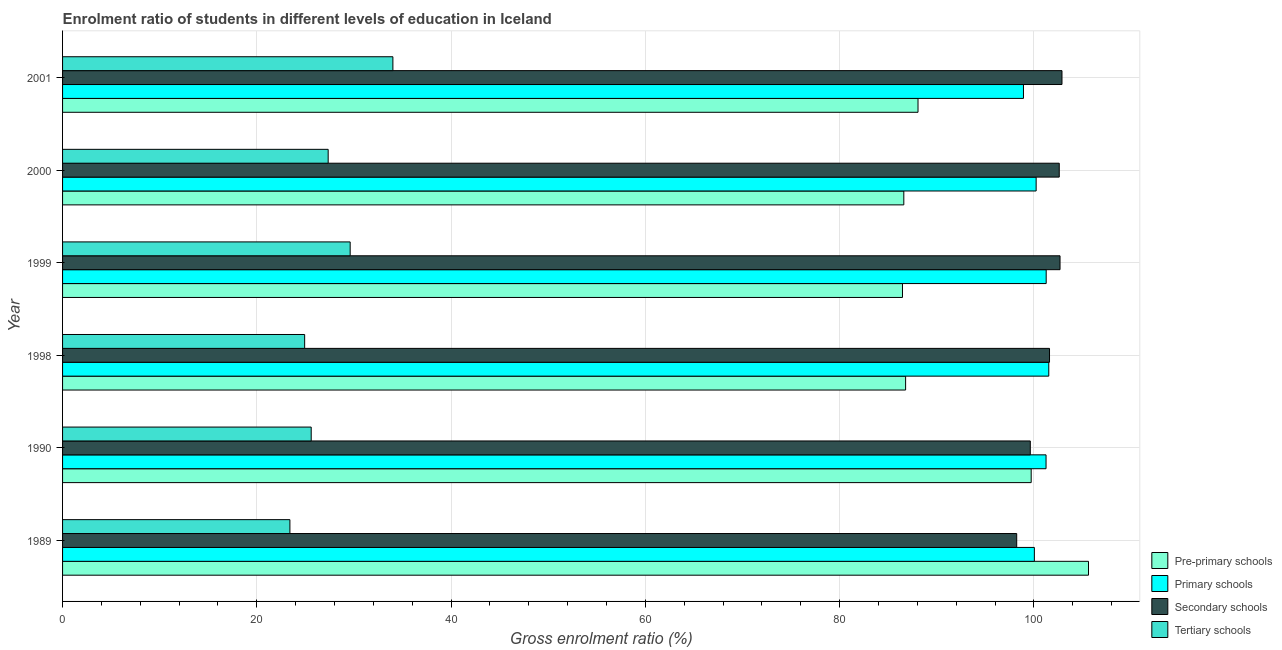How many groups of bars are there?
Offer a very short reply. 6. Are the number of bars on each tick of the Y-axis equal?
Offer a terse response. Yes. How many bars are there on the 5th tick from the bottom?
Your answer should be very brief. 4. In how many cases, is the number of bars for a given year not equal to the number of legend labels?
Keep it short and to the point. 0. What is the gross enrolment ratio in primary schools in 1999?
Your response must be concise. 101.26. Across all years, what is the maximum gross enrolment ratio in tertiary schools?
Give a very brief answer. 34.01. Across all years, what is the minimum gross enrolment ratio in pre-primary schools?
Your answer should be very brief. 86.47. In which year was the gross enrolment ratio in primary schools maximum?
Ensure brevity in your answer.  1998. In which year was the gross enrolment ratio in secondary schools minimum?
Give a very brief answer. 1989. What is the total gross enrolment ratio in pre-primary schools in the graph?
Keep it short and to the point. 553.26. What is the difference between the gross enrolment ratio in tertiary schools in 1989 and that in 1990?
Ensure brevity in your answer.  -2.19. What is the difference between the gross enrolment ratio in tertiary schools in 2001 and the gross enrolment ratio in primary schools in 2000?
Provide a short and direct response. -66.22. What is the average gross enrolment ratio in pre-primary schools per year?
Your response must be concise. 92.21. In the year 1999, what is the difference between the gross enrolment ratio in primary schools and gross enrolment ratio in pre-primary schools?
Your answer should be compact. 14.79. What is the ratio of the gross enrolment ratio in pre-primary schools in 1989 to that in 1999?
Keep it short and to the point. 1.22. Is the difference between the gross enrolment ratio in secondary schools in 2000 and 2001 greater than the difference between the gross enrolment ratio in primary schools in 2000 and 2001?
Make the answer very short. No. What is the difference between the highest and the second highest gross enrolment ratio in tertiary schools?
Your answer should be very brief. 4.4. What is the difference between the highest and the lowest gross enrolment ratio in tertiary schools?
Ensure brevity in your answer.  10.6. In how many years, is the gross enrolment ratio in primary schools greater than the average gross enrolment ratio in primary schools taken over all years?
Give a very brief answer. 3. What does the 4th bar from the top in 1998 represents?
Make the answer very short. Pre-primary schools. What does the 1st bar from the bottom in 1998 represents?
Offer a terse response. Pre-primary schools. How many bars are there?
Your answer should be very brief. 24. How many years are there in the graph?
Make the answer very short. 6. What is the difference between two consecutive major ticks on the X-axis?
Make the answer very short. 20. Are the values on the major ticks of X-axis written in scientific E-notation?
Provide a succinct answer. No. Does the graph contain grids?
Give a very brief answer. Yes. How many legend labels are there?
Make the answer very short. 4. What is the title of the graph?
Ensure brevity in your answer.  Enrolment ratio of students in different levels of education in Iceland. What is the Gross enrolment ratio (%) of Pre-primary schools in 1989?
Provide a succinct answer. 105.62. What is the Gross enrolment ratio (%) in Primary schools in 1989?
Offer a terse response. 100.04. What is the Gross enrolment ratio (%) of Secondary schools in 1989?
Your answer should be very brief. 98.23. What is the Gross enrolment ratio (%) in Tertiary schools in 1989?
Keep it short and to the point. 23.4. What is the Gross enrolment ratio (%) of Pre-primary schools in 1990?
Ensure brevity in your answer.  99.72. What is the Gross enrolment ratio (%) of Primary schools in 1990?
Keep it short and to the point. 101.25. What is the Gross enrolment ratio (%) of Secondary schools in 1990?
Make the answer very short. 99.62. What is the Gross enrolment ratio (%) of Tertiary schools in 1990?
Make the answer very short. 25.6. What is the Gross enrolment ratio (%) in Pre-primary schools in 1998?
Your response must be concise. 86.79. What is the Gross enrolment ratio (%) in Primary schools in 1998?
Ensure brevity in your answer.  101.53. What is the Gross enrolment ratio (%) of Secondary schools in 1998?
Offer a terse response. 101.6. What is the Gross enrolment ratio (%) in Tertiary schools in 1998?
Ensure brevity in your answer.  24.92. What is the Gross enrolment ratio (%) in Pre-primary schools in 1999?
Your answer should be compact. 86.47. What is the Gross enrolment ratio (%) in Primary schools in 1999?
Make the answer very short. 101.26. What is the Gross enrolment ratio (%) of Secondary schools in 1999?
Give a very brief answer. 102.69. What is the Gross enrolment ratio (%) in Tertiary schools in 1999?
Keep it short and to the point. 29.61. What is the Gross enrolment ratio (%) of Pre-primary schools in 2000?
Give a very brief answer. 86.6. What is the Gross enrolment ratio (%) of Primary schools in 2000?
Your answer should be compact. 100.23. What is the Gross enrolment ratio (%) in Secondary schools in 2000?
Give a very brief answer. 102.61. What is the Gross enrolment ratio (%) of Tertiary schools in 2000?
Offer a terse response. 27.34. What is the Gross enrolment ratio (%) in Pre-primary schools in 2001?
Your answer should be very brief. 88.07. What is the Gross enrolment ratio (%) of Primary schools in 2001?
Give a very brief answer. 98.92. What is the Gross enrolment ratio (%) in Secondary schools in 2001?
Your answer should be compact. 102.89. What is the Gross enrolment ratio (%) in Tertiary schools in 2001?
Offer a very short reply. 34.01. Across all years, what is the maximum Gross enrolment ratio (%) of Pre-primary schools?
Your answer should be very brief. 105.62. Across all years, what is the maximum Gross enrolment ratio (%) in Primary schools?
Offer a very short reply. 101.53. Across all years, what is the maximum Gross enrolment ratio (%) in Secondary schools?
Your response must be concise. 102.89. Across all years, what is the maximum Gross enrolment ratio (%) in Tertiary schools?
Ensure brevity in your answer.  34.01. Across all years, what is the minimum Gross enrolment ratio (%) in Pre-primary schools?
Your answer should be very brief. 86.47. Across all years, what is the minimum Gross enrolment ratio (%) in Primary schools?
Offer a very short reply. 98.92. Across all years, what is the minimum Gross enrolment ratio (%) in Secondary schools?
Your answer should be very brief. 98.23. Across all years, what is the minimum Gross enrolment ratio (%) in Tertiary schools?
Offer a terse response. 23.4. What is the total Gross enrolment ratio (%) in Pre-primary schools in the graph?
Ensure brevity in your answer.  553.26. What is the total Gross enrolment ratio (%) in Primary schools in the graph?
Provide a succinct answer. 603.23. What is the total Gross enrolment ratio (%) in Secondary schools in the graph?
Make the answer very short. 607.63. What is the total Gross enrolment ratio (%) of Tertiary schools in the graph?
Provide a short and direct response. 164.88. What is the difference between the Gross enrolment ratio (%) in Pre-primary schools in 1989 and that in 1990?
Your answer should be compact. 5.9. What is the difference between the Gross enrolment ratio (%) of Primary schools in 1989 and that in 1990?
Offer a very short reply. -1.2. What is the difference between the Gross enrolment ratio (%) in Secondary schools in 1989 and that in 1990?
Make the answer very short. -1.4. What is the difference between the Gross enrolment ratio (%) in Tertiary schools in 1989 and that in 1990?
Ensure brevity in your answer.  -2.19. What is the difference between the Gross enrolment ratio (%) of Pre-primary schools in 1989 and that in 1998?
Provide a short and direct response. 18.83. What is the difference between the Gross enrolment ratio (%) in Primary schools in 1989 and that in 1998?
Offer a terse response. -1.48. What is the difference between the Gross enrolment ratio (%) in Secondary schools in 1989 and that in 1998?
Your answer should be compact. -3.38. What is the difference between the Gross enrolment ratio (%) of Tertiary schools in 1989 and that in 1998?
Offer a very short reply. -1.52. What is the difference between the Gross enrolment ratio (%) in Pre-primary schools in 1989 and that in 1999?
Your answer should be compact. 19.15. What is the difference between the Gross enrolment ratio (%) of Primary schools in 1989 and that in 1999?
Ensure brevity in your answer.  -1.22. What is the difference between the Gross enrolment ratio (%) in Secondary schools in 1989 and that in 1999?
Offer a very short reply. -4.46. What is the difference between the Gross enrolment ratio (%) in Tertiary schools in 1989 and that in 1999?
Provide a short and direct response. -6.2. What is the difference between the Gross enrolment ratio (%) in Pre-primary schools in 1989 and that in 2000?
Your answer should be very brief. 19.01. What is the difference between the Gross enrolment ratio (%) in Primary schools in 1989 and that in 2000?
Give a very brief answer. -0.18. What is the difference between the Gross enrolment ratio (%) of Secondary schools in 1989 and that in 2000?
Your answer should be very brief. -4.38. What is the difference between the Gross enrolment ratio (%) of Tertiary schools in 1989 and that in 2000?
Make the answer very short. -3.94. What is the difference between the Gross enrolment ratio (%) in Pre-primary schools in 1989 and that in 2001?
Offer a very short reply. 17.55. What is the difference between the Gross enrolment ratio (%) in Primary schools in 1989 and that in 2001?
Offer a terse response. 1.12. What is the difference between the Gross enrolment ratio (%) of Secondary schools in 1989 and that in 2001?
Ensure brevity in your answer.  -4.66. What is the difference between the Gross enrolment ratio (%) of Tertiary schools in 1989 and that in 2001?
Provide a succinct answer. -10.6. What is the difference between the Gross enrolment ratio (%) of Pre-primary schools in 1990 and that in 1998?
Ensure brevity in your answer.  12.93. What is the difference between the Gross enrolment ratio (%) in Primary schools in 1990 and that in 1998?
Make the answer very short. -0.28. What is the difference between the Gross enrolment ratio (%) in Secondary schools in 1990 and that in 1998?
Provide a succinct answer. -1.98. What is the difference between the Gross enrolment ratio (%) of Tertiary schools in 1990 and that in 1998?
Provide a succinct answer. 0.67. What is the difference between the Gross enrolment ratio (%) of Pre-primary schools in 1990 and that in 1999?
Your response must be concise. 13.25. What is the difference between the Gross enrolment ratio (%) in Primary schools in 1990 and that in 1999?
Your response must be concise. -0.01. What is the difference between the Gross enrolment ratio (%) in Secondary schools in 1990 and that in 1999?
Make the answer very short. -3.06. What is the difference between the Gross enrolment ratio (%) in Tertiary schools in 1990 and that in 1999?
Give a very brief answer. -4.01. What is the difference between the Gross enrolment ratio (%) in Pre-primary schools in 1990 and that in 2000?
Provide a succinct answer. 13.11. What is the difference between the Gross enrolment ratio (%) in Primary schools in 1990 and that in 2000?
Offer a terse response. 1.02. What is the difference between the Gross enrolment ratio (%) of Secondary schools in 1990 and that in 2000?
Your answer should be compact. -2.98. What is the difference between the Gross enrolment ratio (%) in Tertiary schools in 1990 and that in 2000?
Offer a terse response. -1.75. What is the difference between the Gross enrolment ratio (%) in Pre-primary schools in 1990 and that in 2001?
Offer a terse response. 11.65. What is the difference between the Gross enrolment ratio (%) in Primary schools in 1990 and that in 2001?
Offer a terse response. 2.33. What is the difference between the Gross enrolment ratio (%) in Secondary schools in 1990 and that in 2001?
Provide a short and direct response. -3.26. What is the difference between the Gross enrolment ratio (%) in Tertiary schools in 1990 and that in 2001?
Provide a succinct answer. -8.41. What is the difference between the Gross enrolment ratio (%) in Pre-primary schools in 1998 and that in 1999?
Ensure brevity in your answer.  0.32. What is the difference between the Gross enrolment ratio (%) of Primary schools in 1998 and that in 1999?
Offer a terse response. 0.27. What is the difference between the Gross enrolment ratio (%) of Secondary schools in 1998 and that in 1999?
Make the answer very short. -1.08. What is the difference between the Gross enrolment ratio (%) of Tertiary schools in 1998 and that in 1999?
Provide a short and direct response. -4.69. What is the difference between the Gross enrolment ratio (%) of Pre-primary schools in 1998 and that in 2000?
Offer a very short reply. 0.19. What is the difference between the Gross enrolment ratio (%) in Primary schools in 1998 and that in 2000?
Your answer should be compact. 1.3. What is the difference between the Gross enrolment ratio (%) in Secondary schools in 1998 and that in 2000?
Offer a terse response. -1. What is the difference between the Gross enrolment ratio (%) of Tertiary schools in 1998 and that in 2000?
Your response must be concise. -2.42. What is the difference between the Gross enrolment ratio (%) in Pre-primary schools in 1998 and that in 2001?
Your answer should be compact. -1.28. What is the difference between the Gross enrolment ratio (%) of Primary schools in 1998 and that in 2001?
Your answer should be compact. 2.61. What is the difference between the Gross enrolment ratio (%) of Secondary schools in 1998 and that in 2001?
Give a very brief answer. -1.28. What is the difference between the Gross enrolment ratio (%) of Tertiary schools in 1998 and that in 2001?
Ensure brevity in your answer.  -9.08. What is the difference between the Gross enrolment ratio (%) of Pre-primary schools in 1999 and that in 2000?
Provide a succinct answer. -0.14. What is the difference between the Gross enrolment ratio (%) of Primary schools in 1999 and that in 2000?
Ensure brevity in your answer.  1.03. What is the difference between the Gross enrolment ratio (%) of Secondary schools in 1999 and that in 2000?
Give a very brief answer. 0.08. What is the difference between the Gross enrolment ratio (%) of Tertiary schools in 1999 and that in 2000?
Keep it short and to the point. 2.27. What is the difference between the Gross enrolment ratio (%) of Pre-primary schools in 1999 and that in 2001?
Your answer should be compact. -1.6. What is the difference between the Gross enrolment ratio (%) of Primary schools in 1999 and that in 2001?
Your response must be concise. 2.34. What is the difference between the Gross enrolment ratio (%) in Secondary schools in 1999 and that in 2001?
Provide a succinct answer. -0.2. What is the difference between the Gross enrolment ratio (%) of Tertiary schools in 1999 and that in 2001?
Your answer should be very brief. -4.4. What is the difference between the Gross enrolment ratio (%) of Pre-primary schools in 2000 and that in 2001?
Give a very brief answer. -1.46. What is the difference between the Gross enrolment ratio (%) of Primary schools in 2000 and that in 2001?
Your response must be concise. 1.3. What is the difference between the Gross enrolment ratio (%) in Secondary schools in 2000 and that in 2001?
Provide a succinct answer. -0.28. What is the difference between the Gross enrolment ratio (%) in Tertiary schools in 2000 and that in 2001?
Your answer should be very brief. -6.66. What is the difference between the Gross enrolment ratio (%) in Pre-primary schools in 1989 and the Gross enrolment ratio (%) in Primary schools in 1990?
Ensure brevity in your answer.  4.37. What is the difference between the Gross enrolment ratio (%) in Pre-primary schools in 1989 and the Gross enrolment ratio (%) in Secondary schools in 1990?
Make the answer very short. 5.99. What is the difference between the Gross enrolment ratio (%) in Pre-primary schools in 1989 and the Gross enrolment ratio (%) in Tertiary schools in 1990?
Keep it short and to the point. 80.02. What is the difference between the Gross enrolment ratio (%) in Primary schools in 1989 and the Gross enrolment ratio (%) in Secondary schools in 1990?
Make the answer very short. 0.42. What is the difference between the Gross enrolment ratio (%) in Primary schools in 1989 and the Gross enrolment ratio (%) in Tertiary schools in 1990?
Offer a terse response. 74.45. What is the difference between the Gross enrolment ratio (%) of Secondary schools in 1989 and the Gross enrolment ratio (%) of Tertiary schools in 1990?
Offer a terse response. 72.63. What is the difference between the Gross enrolment ratio (%) of Pre-primary schools in 1989 and the Gross enrolment ratio (%) of Primary schools in 1998?
Provide a succinct answer. 4.09. What is the difference between the Gross enrolment ratio (%) of Pre-primary schools in 1989 and the Gross enrolment ratio (%) of Secondary schools in 1998?
Your answer should be compact. 4.01. What is the difference between the Gross enrolment ratio (%) of Pre-primary schools in 1989 and the Gross enrolment ratio (%) of Tertiary schools in 1998?
Keep it short and to the point. 80.69. What is the difference between the Gross enrolment ratio (%) of Primary schools in 1989 and the Gross enrolment ratio (%) of Secondary schools in 1998?
Give a very brief answer. -1.56. What is the difference between the Gross enrolment ratio (%) of Primary schools in 1989 and the Gross enrolment ratio (%) of Tertiary schools in 1998?
Provide a succinct answer. 75.12. What is the difference between the Gross enrolment ratio (%) of Secondary schools in 1989 and the Gross enrolment ratio (%) of Tertiary schools in 1998?
Offer a terse response. 73.3. What is the difference between the Gross enrolment ratio (%) in Pre-primary schools in 1989 and the Gross enrolment ratio (%) in Primary schools in 1999?
Provide a short and direct response. 4.36. What is the difference between the Gross enrolment ratio (%) of Pre-primary schools in 1989 and the Gross enrolment ratio (%) of Secondary schools in 1999?
Make the answer very short. 2.93. What is the difference between the Gross enrolment ratio (%) in Pre-primary schools in 1989 and the Gross enrolment ratio (%) in Tertiary schools in 1999?
Offer a very short reply. 76.01. What is the difference between the Gross enrolment ratio (%) in Primary schools in 1989 and the Gross enrolment ratio (%) in Secondary schools in 1999?
Provide a short and direct response. -2.64. What is the difference between the Gross enrolment ratio (%) in Primary schools in 1989 and the Gross enrolment ratio (%) in Tertiary schools in 1999?
Offer a very short reply. 70.44. What is the difference between the Gross enrolment ratio (%) of Secondary schools in 1989 and the Gross enrolment ratio (%) of Tertiary schools in 1999?
Provide a succinct answer. 68.62. What is the difference between the Gross enrolment ratio (%) in Pre-primary schools in 1989 and the Gross enrolment ratio (%) in Primary schools in 2000?
Ensure brevity in your answer.  5.39. What is the difference between the Gross enrolment ratio (%) in Pre-primary schools in 1989 and the Gross enrolment ratio (%) in Secondary schools in 2000?
Ensure brevity in your answer.  3.01. What is the difference between the Gross enrolment ratio (%) in Pre-primary schools in 1989 and the Gross enrolment ratio (%) in Tertiary schools in 2000?
Your response must be concise. 78.27. What is the difference between the Gross enrolment ratio (%) of Primary schools in 1989 and the Gross enrolment ratio (%) of Secondary schools in 2000?
Provide a succinct answer. -2.56. What is the difference between the Gross enrolment ratio (%) in Primary schools in 1989 and the Gross enrolment ratio (%) in Tertiary schools in 2000?
Ensure brevity in your answer.  72.7. What is the difference between the Gross enrolment ratio (%) of Secondary schools in 1989 and the Gross enrolment ratio (%) of Tertiary schools in 2000?
Your answer should be very brief. 70.88. What is the difference between the Gross enrolment ratio (%) in Pre-primary schools in 1989 and the Gross enrolment ratio (%) in Primary schools in 2001?
Make the answer very short. 6.7. What is the difference between the Gross enrolment ratio (%) of Pre-primary schools in 1989 and the Gross enrolment ratio (%) of Secondary schools in 2001?
Offer a very short reply. 2.73. What is the difference between the Gross enrolment ratio (%) of Pre-primary schools in 1989 and the Gross enrolment ratio (%) of Tertiary schools in 2001?
Provide a succinct answer. 71.61. What is the difference between the Gross enrolment ratio (%) in Primary schools in 1989 and the Gross enrolment ratio (%) in Secondary schools in 2001?
Provide a short and direct response. -2.84. What is the difference between the Gross enrolment ratio (%) of Primary schools in 1989 and the Gross enrolment ratio (%) of Tertiary schools in 2001?
Provide a succinct answer. 66.04. What is the difference between the Gross enrolment ratio (%) in Secondary schools in 1989 and the Gross enrolment ratio (%) in Tertiary schools in 2001?
Offer a very short reply. 64.22. What is the difference between the Gross enrolment ratio (%) of Pre-primary schools in 1990 and the Gross enrolment ratio (%) of Primary schools in 1998?
Your response must be concise. -1.81. What is the difference between the Gross enrolment ratio (%) in Pre-primary schools in 1990 and the Gross enrolment ratio (%) in Secondary schools in 1998?
Provide a succinct answer. -1.89. What is the difference between the Gross enrolment ratio (%) of Pre-primary schools in 1990 and the Gross enrolment ratio (%) of Tertiary schools in 1998?
Keep it short and to the point. 74.79. What is the difference between the Gross enrolment ratio (%) in Primary schools in 1990 and the Gross enrolment ratio (%) in Secondary schools in 1998?
Your answer should be very brief. -0.36. What is the difference between the Gross enrolment ratio (%) in Primary schools in 1990 and the Gross enrolment ratio (%) in Tertiary schools in 1998?
Offer a very short reply. 76.32. What is the difference between the Gross enrolment ratio (%) in Secondary schools in 1990 and the Gross enrolment ratio (%) in Tertiary schools in 1998?
Give a very brief answer. 74.7. What is the difference between the Gross enrolment ratio (%) in Pre-primary schools in 1990 and the Gross enrolment ratio (%) in Primary schools in 1999?
Offer a terse response. -1.54. What is the difference between the Gross enrolment ratio (%) of Pre-primary schools in 1990 and the Gross enrolment ratio (%) of Secondary schools in 1999?
Your response must be concise. -2.97. What is the difference between the Gross enrolment ratio (%) in Pre-primary schools in 1990 and the Gross enrolment ratio (%) in Tertiary schools in 1999?
Make the answer very short. 70.11. What is the difference between the Gross enrolment ratio (%) in Primary schools in 1990 and the Gross enrolment ratio (%) in Secondary schools in 1999?
Provide a succinct answer. -1.44. What is the difference between the Gross enrolment ratio (%) of Primary schools in 1990 and the Gross enrolment ratio (%) of Tertiary schools in 1999?
Keep it short and to the point. 71.64. What is the difference between the Gross enrolment ratio (%) of Secondary schools in 1990 and the Gross enrolment ratio (%) of Tertiary schools in 1999?
Keep it short and to the point. 70.02. What is the difference between the Gross enrolment ratio (%) in Pre-primary schools in 1990 and the Gross enrolment ratio (%) in Primary schools in 2000?
Your response must be concise. -0.51. What is the difference between the Gross enrolment ratio (%) in Pre-primary schools in 1990 and the Gross enrolment ratio (%) in Secondary schools in 2000?
Ensure brevity in your answer.  -2.89. What is the difference between the Gross enrolment ratio (%) in Pre-primary schools in 1990 and the Gross enrolment ratio (%) in Tertiary schools in 2000?
Ensure brevity in your answer.  72.37. What is the difference between the Gross enrolment ratio (%) in Primary schools in 1990 and the Gross enrolment ratio (%) in Secondary schools in 2000?
Give a very brief answer. -1.36. What is the difference between the Gross enrolment ratio (%) in Primary schools in 1990 and the Gross enrolment ratio (%) in Tertiary schools in 2000?
Provide a succinct answer. 73.9. What is the difference between the Gross enrolment ratio (%) in Secondary schools in 1990 and the Gross enrolment ratio (%) in Tertiary schools in 2000?
Ensure brevity in your answer.  72.28. What is the difference between the Gross enrolment ratio (%) in Pre-primary schools in 1990 and the Gross enrolment ratio (%) in Primary schools in 2001?
Your answer should be compact. 0.8. What is the difference between the Gross enrolment ratio (%) in Pre-primary schools in 1990 and the Gross enrolment ratio (%) in Secondary schools in 2001?
Offer a very short reply. -3.17. What is the difference between the Gross enrolment ratio (%) of Pre-primary schools in 1990 and the Gross enrolment ratio (%) of Tertiary schools in 2001?
Your response must be concise. 65.71. What is the difference between the Gross enrolment ratio (%) in Primary schools in 1990 and the Gross enrolment ratio (%) in Secondary schools in 2001?
Offer a very short reply. -1.64. What is the difference between the Gross enrolment ratio (%) of Primary schools in 1990 and the Gross enrolment ratio (%) of Tertiary schools in 2001?
Provide a short and direct response. 67.24. What is the difference between the Gross enrolment ratio (%) in Secondary schools in 1990 and the Gross enrolment ratio (%) in Tertiary schools in 2001?
Offer a terse response. 65.62. What is the difference between the Gross enrolment ratio (%) of Pre-primary schools in 1998 and the Gross enrolment ratio (%) of Primary schools in 1999?
Your answer should be very brief. -14.47. What is the difference between the Gross enrolment ratio (%) of Pre-primary schools in 1998 and the Gross enrolment ratio (%) of Secondary schools in 1999?
Make the answer very short. -15.9. What is the difference between the Gross enrolment ratio (%) in Pre-primary schools in 1998 and the Gross enrolment ratio (%) in Tertiary schools in 1999?
Provide a short and direct response. 57.18. What is the difference between the Gross enrolment ratio (%) of Primary schools in 1998 and the Gross enrolment ratio (%) of Secondary schools in 1999?
Offer a very short reply. -1.16. What is the difference between the Gross enrolment ratio (%) of Primary schools in 1998 and the Gross enrolment ratio (%) of Tertiary schools in 1999?
Ensure brevity in your answer.  71.92. What is the difference between the Gross enrolment ratio (%) in Secondary schools in 1998 and the Gross enrolment ratio (%) in Tertiary schools in 1999?
Keep it short and to the point. 71.99. What is the difference between the Gross enrolment ratio (%) in Pre-primary schools in 1998 and the Gross enrolment ratio (%) in Primary schools in 2000?
Offer a terse response. -13.44. What is the difference between the Gross enrolment ratio (%) in Pre-primary schools in 1998 and the Gross enrolment ratio (%) in Secondary schools in 2000?
Provide a succinct answer. -15.82. What is the difference between the Gross enrolment ratio (%) of Pre-primary schools in 1998 and the Gross enrolment ratio (%) of Tertiary schools in 2000?
Offer a terse response. 59.45. What is the difference between the Gross enrolment ratio (%) of Primary schools in 1998 and the Gross enrolment ratio (%) of Secondary schools in 2000?
Offer a terse response. -1.08. What is the difference between the Gross enrolment ratio (%) of Primary schools in 1998 and the Gross enrolment ratio (%) of Tertiary schools in 2000?
Your answer should be very brief. 74.18. What is the difference between the Gross enrolment ratio (%) in Secondary schools in 1998 and the Gross enrolment ratio (%) in Tertiary schools in 2000?
Provide a succinct answer. 74.26. What is the difference between the Gross enrolment ratio (%) in Pre-primary schools in 1998 and the Gross enrolment ratio (%) in Primary schools in 2001?
Your answer should be compact. -12.13. What is the difference between the Gross enrolment ratio (%) of Pre-primary schools in 1998 and the Gross enrolment ratio (%) of Secondary schools in 2001?
Offer a terse response. -16.1. What is the difference between the Gross enrolment ratio (%) in Pre-primary schools in 1998 and the Gross enrolment ratio (%) in Tertiary schools in 2001?
Provide a succinct answer. 52.78. What is the difference between the Gross enrolment ratio (%) of Primary schools in 1998 and the Gross enrolment ratio (%) of Secondary schools in 2001?
Your answer should be compact. -1.36. What is the difference between the Gross enrolment ratio (%) of Primary schools in 1998 and the Gross enrolment ratio (%) of Tertiary schools in 2001?
Your answer should be compact. 67.52. What is the difference between the Gross enrolment ratio (%) of Secondary schools in 1998 and the Gross enrolment ratio (%) of Tertiary schools in 2001?
Make the answer very short. 67.6. What is the difference between the Gross enrolment ratio (%) of Pre-primary schools in 1999 and the Gross enrolment ratio (%) of Primary schools in 2000?
Provide a short and direct response. -13.76. What is the difference between the Gross enrolment ratio (%) in Pre-primary schools in 1999 and the Gross enrolment ratio (%) in Secondary schools in 2000?
Ensure brevity in your answer.  -16.14. What is the difference between the Gross enrolment ratio (%) in Pre-primary schools in 1999 and the Gross enrolment ratio (%) in Tertiary schools in 2000?
Provide a short and direct response. 59.12. What is the difference between the Gross enrolment ratio (%) in Primary schools in 1999 and the Gross enrolment ratio (%) in Secondary schools in 2000?
Your response must be concise. -1.35. What is the difference between the Gross enrolment ratio (%) in Primary schools in 1999 and the Gross enrolment ratio (%) in Tertiary schools in 2000?
Keep it short and to the point. 73.92. What is the difference between the Gross enrolment ratio (%) of Secondary schools in 1999 and the Gross enrolment ratio (%) of Tertiary schools in 2000?
Make the answer very short. 75.34. What is the difference between the Gross enrolment ratio (%) of Pre-primary schools in 1999 and the Gross enrolment ratio (%) of Primary schools in 2001?
Ensure brevity in your answer.  -12.45. What is the difference between the Gross enrolment ratio (%) of Pre-primary schools in 1999 and the Gross enrolment ratio (%) of Secondary schools in 2001?
Your answer should be very brief. -16.42. What is the difference between the Gross enrolment ratio (%) in Pre-primary schools in 1999 and the Gross enrolment ratio (%) in Tertiary schools in 2001?
Give a very brief answer. 52.46. What is the difference between the Gross enrolment ratio (%) of Primary schools in 1999 and the Gross enrolment ratio (%) of Secondary schools in 2001?
Give a very brief answer. -1.63. What is the difference between the Gross enrolment ratio (%) of Primary schools in 1999 and the Gross enrolment ratio (%) of Tertiary schools in 2001?
Provide a succinct answer. 67.25. What is the difference between the Gross enrolment ratio (%) of Secondary schools in 1999 and the Gross enrolment ratio (%) of Tertiary schools in 2001?
Offer a very short reply. 68.68. What is the difference between the Gross enrolment ratio (%) of Pre-primary schools in 2000 and the Gross enrolment ratio (%) of Primary schools in 2001?
Ensure brevity in your answer.  -12.32. What is the difference between the Gross enrolment ratio (%) in Pre-primary schools in 2000 and the Gross enrolment ratio (%) in Secondary schools in 2001?
Provide a succinct answer. -16.28. What is the difference between the Gross enrolment ratio (%) of Pre-primary schools in 2000 and the Gross enrolment ratio (%) of Tertiary schools in 2001?
Provide a succinct answer. 52.6. What is the difference between the Gross enrolment ratio (%) in Primary schools in 2000 and the Gross enrolment ratio (%) in Secondary schools in 2001?
Ensure brevity in your answer.  -2.66. What is the difference between the Gross enrolment ratio (%) of Primary schools in 2000 and the Gross enrolment ratio (%) of Tertiary schools in 2001?
Your answer should be very brief. 66.22. What is the difference between the Gross enrolment ratio (%) in Secondary schools in 2000 and the Gross enrolment ratio (%) in Tertiary schools in 2001?
Your answer should be compact. 68.6. What is the average Gross enrolment ratio (%) in Pre-primary schools per year?
Offer a terse response. 92.21. What is the average Gross enrolment ratio (%) in Primary schools per year?
Provide a succinct answer. 100.54. What is the average Gross enrolment ratio (%) in Secondary schools per year?
Your response must be concise. 101.27. What is the average Gross enrolment ratio (%) of Tertiary schools per year?
Provide a short and direct response. 27.48. In the year 1989, what is the difference between the Gross enrolment ratio (%) in Pre-primary schools and Gross enrolment ratio (%) in Primary schools?
Make the answer very short. 5.57. In the year 1989, what is the difference between the Gross enrolment ratio (%) of Pre-primary schools and Gross enrolment ratio (%) of Secondary schools?
Keep it short and to the point. 7.39. In the year 1989, what is the difference between the Gross enrolment ratio (%) of Pre-primary schools and Gross enrolment ratio (%) of Tertiary schools?
Keep it short and to the point. 82.21. In the year 1989, what is the difference between the Gross enrolment ratio (%) in Primary schools and Gross enrolment ratio (%) in Secondary schools?
Give a very brief answer. 1.82. In the year 1989, what is the difference between the Gross enrolment ratio (%) in Primary schools and Gross enrolment ratio (%) in Tertiary schools?
Your answer should be very brief. 76.64. In the year 1989, what is the difference between the Gross enrolment ratio (%) in Secondary schools and Gross enrolment ratio (%) in Tertiary schools?
Give a very brief answer. 74.82. In the year 1990, what is the difference between the Gross enrolment ratio (%) of Pre-primary schools and Gross enrolment ratio (%) of Primary schools?
Your response must be concise. -1.53. In the year 1990, what is the difference between the Gross enrolment ratio (%) in Pre-primary schools and Gross enrolment ratio (%) in Secondary schools?
Ensure brevity in your answer.  0.09. In the year 1990, what is the difference between the Gross enrolment ratio (%) of Pre-primary schools and Gross enrolment ratio (%) of Tertiary schools?
Make the answer very short. 74.12. In the year 1990, what is the difference between the Gross enrolment ratio (%) in Primary schools and Gross enrolment ratio (%) in Secondary schools?
Provide a succinct answer. 1.62. In the year 1990, what is the difference between the Gross enrolment ratio (%) in Primary schools and Gross enrolment ratio (%) in Tertiary schools?
Keep it short and to the point. 75.65. In the year 1990, what is the difference between the Gross enrolment ratio (%) in Secondary schools and Gross enrolment ratio (%) in Tertiary schools?
Your answer should be compact. 74.03. In the year 1998, what is the difference between the Gross enrolment ratio (%) in Pre-primary schools and Gross enrolment ratio (%) in Primary schools?
Make the answer very short. -14.74. In the year 1998, what is the difference between the Gross enrolment ratio (%) of Pre-primary schools and Gross enrolment ratio (%) of Secondary schools?
Your answer should be very brief. -14.81. In the year 1998, what is the difference between the Gross enrolment ratio (%) in Pre-primary schools and Gross enrolment ratio (%) in Tertiary schools?
Your response must be concise. 61.87. In the year 1998, what is the difference between the Gross enrolment ratio (%) in Primary schools and Gross enrolment ratio (%) in Secondary schools?
Your response must be concise. -0.08. In the year 1998, what is the difference between the Gross enrolment ratio (%) of Primary schools and Gross enrolment ratio (%) of Tertiary schools?
Provide a succinct answer. 76.6. In the year 1998, what is the difference between the Gross enrolment ratio (%) of Secondary schools and Gross enrolment ratio (%) of Tertiary schools?
Provide a succinct answer. 76.68. In the year 1999, what is the difference between the Gross enrolment ratio (%) of Pre-primary schools and Gross enrolment ratio (%) of Primary schools?
Ensure brevity in your answer.  -14.79. In the year 1999, what is the difference between the Gross enrolment ratio (%) in Pre-primary schools and Gross enrolment ratio (%) in Secondary schools?
Your answer should be compact. -16.22. In the year 1999, what is the difference between the Gross enrolment ratio (%) in Pre-primary schools and Gross enrolment ratio (%) in Tertiary schools?
Ensure brevity in your answer.  56.86. In the year 1999, what is the difference between the Gross enrolment ratio (%) in Primary schools and Gross enrolment ratio (%) in Secondary schools?
Provide a short and direct response. -1.43. In the year 1999, what is the difference between the Gross enrolment ratio (%) in Primary schools and Gross enrolment ratio (%) in Tertiary schools?
Give a very brief answer. 71.65. In the year 1999, what is the difference between the Gross enrolment ratio (%) of Secondary schools and Gross enrolment ratio (%) of Tertiary schools?
Ensure brevity in your answer.  73.08. In the year 2000, what is the difference between the Gross enrolment ratio (%) in Pre-primary schools and Gross enrolment ratio (%) in Primary schools?
Give a very brief answer. -13.62. In the year 2000, what is the difference between the Gross enrolment ratio (%) of Pre-primary schools and Gross enrolment ratio (%) of Secondary schools?
Offer a terse response. -16. In the year 2000, what is the difference between the Gross enrolment ratio (%) in Pre-primary schools and Gross enrolment ratio (%) in Tertiary schools?
Make the answer very short. 59.26. In the year 2000, what is the difference between the Gross enrolment ratio (%) in Primary schools and Gross enrolment ratio (%) in Secondary schools?
Offer a very short reply. -2.38. In the year 2000, what is the difference between the Gross enrolment ratio (%) of Primary schools and Gross enrolment ratio (%) of Tertiary schools?
Provide a short and direct response. 72.88. In the year 2000, what is the difference between the Gross enrolment ratio (%) of Secondary schools and Gross enrolment ratio (%) of Tertiary schools?
Provide a succinct answer. 75.26. In the year 2001, what is the difference between the Gross enrolment ratio (%) of Pre-primary schools and Gross enrolment ratio (%) of Primary schools?
Your response must be concise. -10.86. In the year 2001, what is the difference between the Gross enrolment ratio (%) in Pre-primary schools and Gross enrolment ratio (%) in Secondary schools?
Keep it short and to the point. -14.82. In the year 2001, what is the difference between the Gross enrolment ratio (%) in Pre-primary schools and Gross enrolment ratio (%) in Tertiary schools?
Keep it short and to the point. 54.06. In the year 2001, what is the difference between the Gross enrolment ratio (%) in Primary schools and Gross enrolment ratio (%) in Secondary schools?
Give a very brief answer. -3.97. In the year 2001, what is the difference between the Gross enrolment ratio (%) of Primary schools and Gross enrolment ratio (%) of Tertiary schools?
Keep it short and to the point. 64.92. In the year 2001, what is the difference between the Gross enrolment ratio (%) in Secondary schools and Gross enrolment ratio (%) in Tertiary schools?
Your answer should be compact. 68.88. What is the ratio of the Gross enrolment ratio (%) of Pre-primary schools in 1989 to that in 1990?
Give a very brief answer. 1.06. What is the ratio of the Gross enrolment ratio (%) of Primary schools in 1989 to that in 1990?
Ensure brevity in your answer.  0.99. What is the ratio of the Gross enrolment ratio (%) in Secondary schools in 1989 to that in 1990?
Make the answer very short. 0.99. What is the ratio of the Gross enrolment ratio (%) of Tertiary schools in 1989 to that in 1990?
Give a very brief answer. 0.91. What is the ratio of the Gross enrolment ratio (%) of Pre-primary schools in 1989 to that in 1998?
Make the answer very short. 1.22. What is the ratio of the Gross enrolment ratio (%) in Primary schools in 1989 to that in 1998?
Your response must be concise. 0.99. What is the ratio of the Gross enrolment ratio (%) in Secondary schools in 1989 to that in 1998?
Your answer should be compact. 0.97. What is the ratio of the Gross enrolment ratio (%) of Tertiary schools in 1989 to that in 1998?
Offer a terse response. 0.94. What is the ratio of the Gross enrolment ratio (%) in Pre-primary schools in 1989 to that in 1999?
Make the answer very short. 1.22. What is the ratio of the Gross enrolment ratio (%) of Secondary schools in 1989 to that in 1999?
Offer a terse response. 0.96. What is the ratio of the Gross enrolment ratio (%) in Tertiary schools in 1989 to that in 1999?
Give a very brief answer. 0.79. What is the ratio of the Gross enrolment ratio (%) of Pre-primary schools in 1989 to that in 2000?
Provide a succinct answer. 1.22. What is the ratio of the Gross enrolment ratio (%) in Secondary schools in 1989 to that in 2000?
Offer a terse response. 0.96. What is the ratio of the Gross enrolment ratio (%) in Tertiary schools in 1989 to that in 2000?
Offer a terse response. 0.86. What is the ratio of the Gross enrolment ratio (%) of Pre-primary schools in 1989 to that in 2001?
Provide a short and direct response. 1.2. What is the ratio of the Gross enrolment ratio (%) in Primary schools in 1989 to that in 2001?
Your answer should be very brief. 1.01. What is the ratio of the Gross enrolment ratio (%) of Secondary schools in 1989 to that in 2001?
Keep it short and to the point. 0.95. What is the ratio of the Gross enrolment ratio (%) of Tertiary schools in 1989 to that in 2001?
Provide a succinct answer. 0.69. What is the ratio of the Gross enrolment ratio (%) of Pre-primary schools in 1990 to that in 1998?
Offer a very short reply. 1.15. What is the ratio of the Gross enrolment ratio (%) in Secondary schools in 1990 to that in 1998?
Provide a succinct answer. 0.98. What is the ratio of the Gross enrolment ratio (%) of Tertiary schools in 1990 to that in 1998?
Provide a succinct answer. 1.03. What is the ratio of the Gross enrolment ratio (%) in Pre-primary schools in 1990 to that in 1999?
Offer a very short reply. 1.15. What is the ratio of the Gross enrolment ratio (%) of Secondary schools in 1990 to that in 1999?
Offer a terse response. 0.97. What is the ratio of the Gross enrolment ratio (%) in Tertiary schools in 1990 to that in 1999?
Your response must be concise. 0.86. What is the ratio of the Gross enrolment ratio (%) in Pre-primary schools in 1990 to that in 2000?
Offer a terse response. 1.15. What is the ratio of the Gross enrolment ratio (%) in Primary schools in 1990 to that in 2000?
Your response must be concise. 1.01. What is the ratio of the Gross enrolment ratio (%) in Secondary schools in 1990 to that in 2000?
Your answer should be very brief. 0.97. What is the ratio of the Gross enrolment ratio (%) in Tertiary schools in 1990 to that in 2000?
Give a very brief answer. 0.94. What is the ratio of the Gross enrolment ratio (%) of Pre-primary schools in 1990 to that in 2001?
Your response must be concise. 1.13. What is the ratio of the Gross enrolment ratio (%) in Primary schools in 1990 to that in 2001?
Ensure brevity in your answer.  1.02. What is the ratio of the Gross enrolment ratio (%) of Secondary schools in 1990 to that in 2001?
Provide a short and direct response. 0.97. What is the ratio of the Gross enrolment ratio (%) in Tertiary schools in 1990 to that in 2001?
Provide a short and direct response. 0.75. What is the ratio of the Gross enrolment ratio (%) of Pre-primary schools in 1998 to that in 1999?
Provide a succinct answer. 1. What is the ratio of the Gross enrolment ratio (%) in Tertiary schools in 1998 to that in 1999?
Your answer should be compact. 0.84. What is the ratio of the Gross enrolment ratio (%) of Primary schools in 1998 to that in 2000?
Ensure brevity in your answer.  1.01. What is the ratio of the Gross enrolment ratio (%) of Secondary schools in 1998 to that in 2000?
Make the answer very short. 0.99. What is the ratio of the Gross enrolment ratio (%) of Tertiary schools in 1998 to that in 2000?
Provide a succinct answer. 0.91. What is the ratio of the Gross enrolment ratio (%) in Pre-primary schools in 1998 to that in 2001?
Your response must be concise. 0.99. What is the ratio of the Gross enrolment ratio (%) in Primary schools in 1998 to that in 2001?
Provide a succinct answer. 1.03. What is the ratio of the Gross enrolment ratio (%) in Secondary schools in 1998 to that in 2001?
Provide a succinct answer. 0.99. What is the ratio of the Gross enrolment ratio (%) of Tertiary schools in 1998 to that in 2001?
Your answer should be compact. 0.73. What is the ratio of the Gross enrolment ratio (%) in Primary schools in 1999 to that in 2000?
Offer a very short reply. 1.01. What is the ratio of the Gross enrolment ratio (%) in Tertiary schools in 1999 to that in 2000?
Provide a succinct answer. 1.08. What is the ratio of the Gross enrolment ratio (%) in Pre-primary schools in 1999 to that in 2001?
Your answer should be compact. 0.98. What is the ratio of the Gross enrolment ratio (%) of Primary schools in 1999 to that in 2001?
Give a very brief answer. 1.02. What is the ratio of the Gross enrolment ratio (%) in Tertiary schools in 1999 to that in 2001?
Make the answer very short. 0.87. What is the ratio of the Gross enrolment ratio (%) of Pre-primary schools in 2000 to that in 2001?
Your answer should be compact. 0.98. What is the ratio of the Gross enrolment ratio (%) in Primary schools in 2000 to that in 2001?
Offer a terse response. 1.01. What is the ratio of the Gross enrolment ratio (%) of Secondary schools in 2000 to that in 2001?
Offer a very short reply. 1. What is the ratio of the Gross enrolment ratio (%) in Tertiary schools in 2000 to that in 2001?
Your answer should be compact. 0.8. What is the difference between the highest and the second highest Gross enrolment ratio (%) of Pre-primary schools?
Keep it short and to the point. 5.9. What is the difference between the highest and the second highest Gross enrolment ratio (%) in Primary schools?
Your response must be concise. 0.27. What is the difference between the highest and the second highest Gross enrolment ratio (%) of Secondary schools?
Your answer should be compact. 0.2. What is the difference between the highest and the second highest Gross enrolment ratio (%) in Tertiary schools?
Offer a very short reply. 4.4. What is the difference between the highest and the lowest Gross enrolment ratio (%) of Pre-primary schools?
Make the answer very short. 19.15. What is the difference between the highest and the lowest Gross enrolment ratio (%) in Primary schools?
Provide a succinct answer. 2.61. What is the difference between the highest and the lowest Gross enrolment ratio (%) of Secondary schools?
Your response must be concise. 4.66. What is the difference between the highest and the lowest Gross enrolment ratio (%) of Tertiary schools?
Provide a short and direct response. 10.6. 